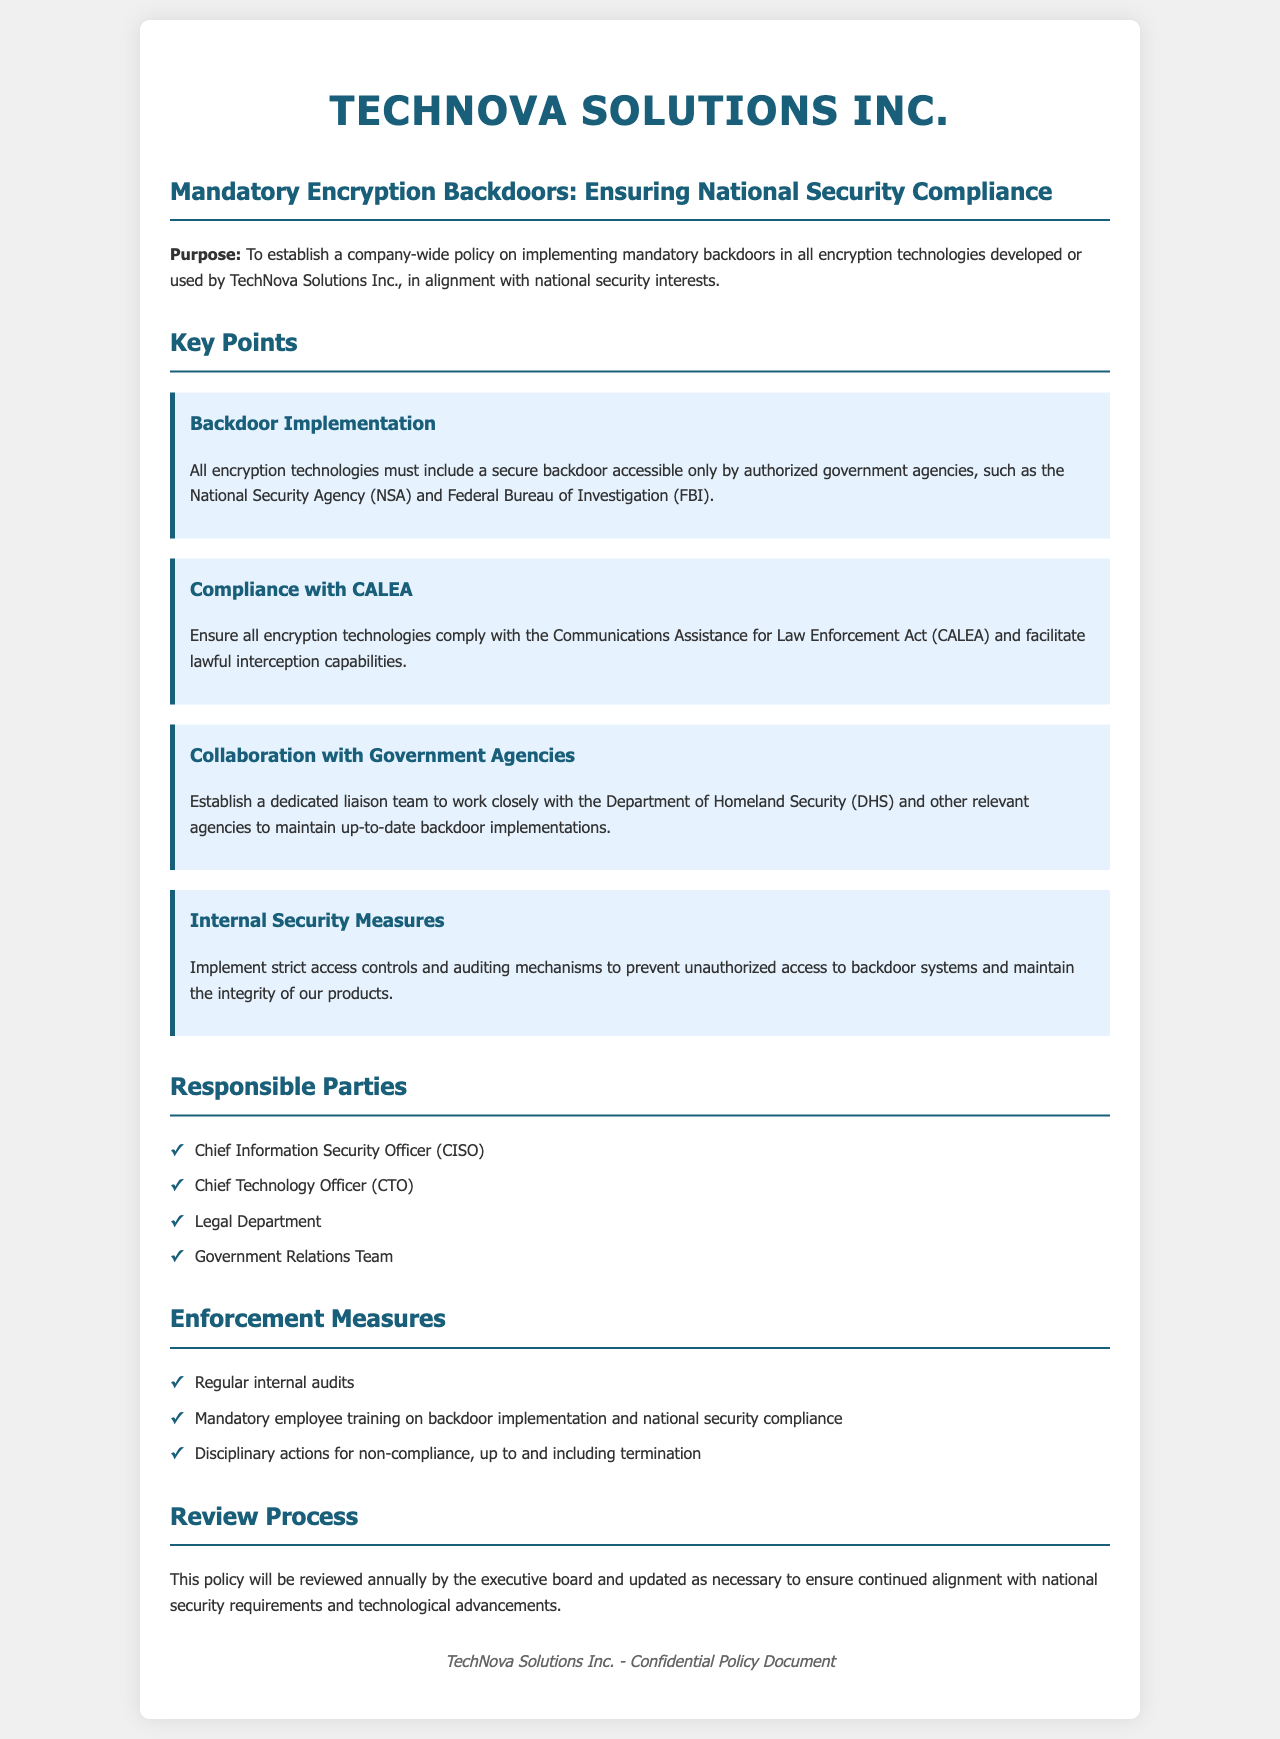What is the purpose of the policy? The purpose is to establish a company-wide policy on implementing mandatory backdoors in encryption technologies developed or used by TechNova Solutions Inc., in alignment with national security interests.
Answer: To establish a company-wide policy on implementing mandatory backdoors in encryption technologies What must all encryption technologies include? The document states that all encryption technologies must include a secure backdoor accessible only by authorized government agencies.
Answer: A secure backdoor Who will be regularly audited for compliance? The enforcement measures include regular internal audits to ensure compliance with the policy.
Answer: Regular internal audits Which Act must be complied with according to the policy? The policy specifies that all encryption technologies must comply with the Communications Assistance for Law Enforcement Act.
Answer: CALEA What is the role of the Chief Information Security Officer? The CISO is listed as one of the responsible parties overseeing the implementation of this encryption policy.
Answer: Responsible party What is the review frequency of the policy? The document states that this policy will be reviewed annually by the executive board.
Answer: Annually 